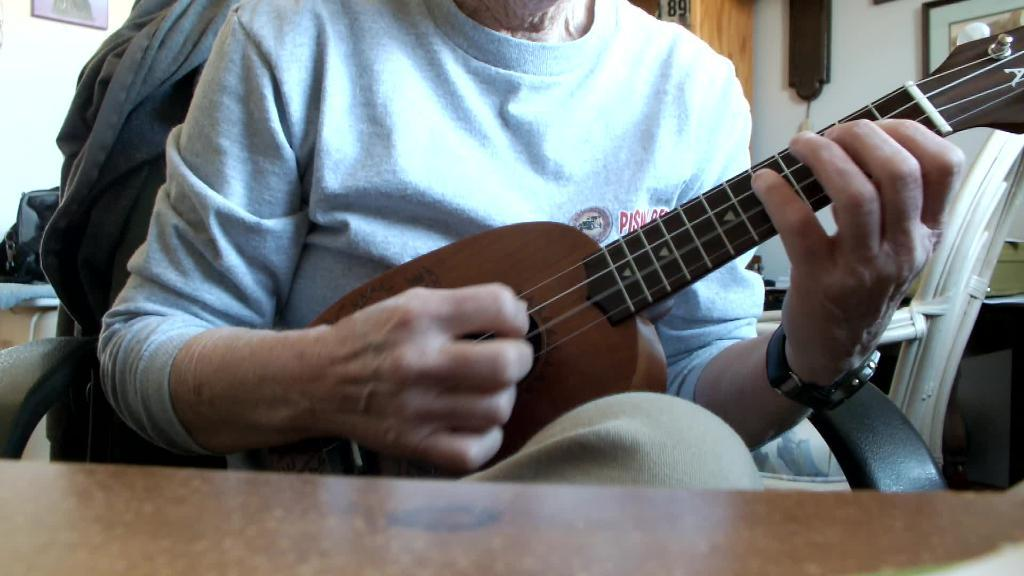What is the main subject of the image? There is a person in the image. What is the person holding in the image? The person is holding a musical instrument. What type of furniture is present in the image? There is a chair and a table in the image. What type of yak can be seen interacting with the musical instrument in the image? There is no yak present in the image, and therefore no such interaction can be observed. What type of food is being prepared on the table in the image? There is no food preparation visible in the image; only a person holding a musical instrument and a table are present. 